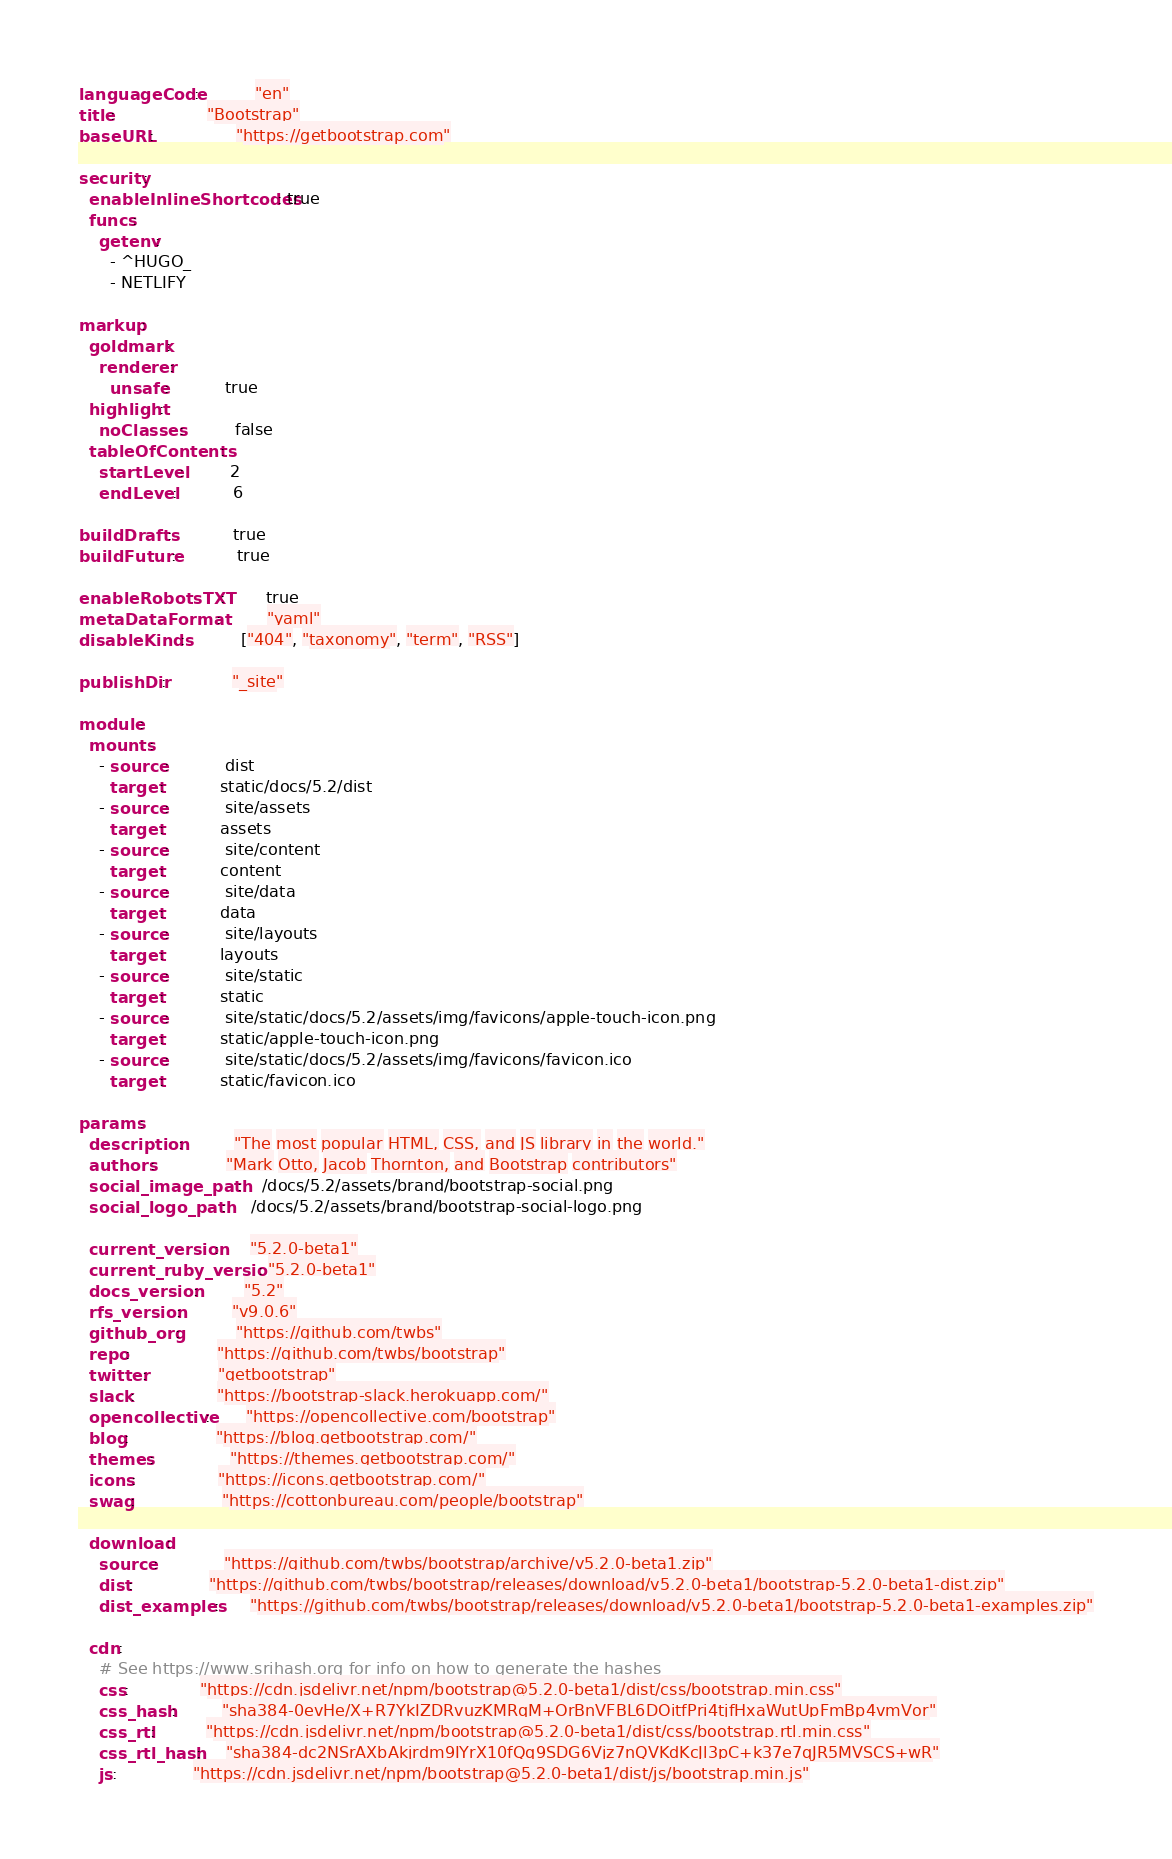<code> <loc_0><loc_0><loc_500><loc_500><_YAML_>languageCode:           "en"
title:                  "Bootstrap"
baseURL:                "https://getbootstrap.com"

security:
  enableInlineShortcodes: true
  funcs:
    getenv:
      - ^HUGO_
      - NETLIFY

markup:
  goldmark:
    renderer:
      unsafe:           true
  highlight:
    noClasses:          false
  tableOfContents:
    startLevel:         2
    endLevel:           6

buildDrafts:            true
buildFuture:            true

enableRobotsTXT:        true
metaDataFormat:         "yaml"
disableKinds:           ["404", "taxonomy", "term", "RSS"]

publishDir:             "_site"

module:
  mounts:
    - source:           dist
      target:           static/docs/5.2/dist
    - source:           site/assets
      target:           assets
    - source:           site/content
      target:           content
    - source:           site/data
      target:           data
    - source:           site/layouts
      target:           layouts
    - source:           site/static
      target:           static
    - source:           site/static/docs/5.2/assets/img/favicons/apple-touch-icon.png
      target:           static/apple-touch-icon.png
    - source:           site/static/docs/5.2/assets/img/favicons/favicon.ico
      target:           static/favicon.ico

params:
  description:          "The most popular HTML, CSS, and JS library in the world."
  authors:              "Mark Otto, Jacob Thornton, and Bootstrap contributors"
  social_image_path:    /docs/5.2/assets/brand/bootstrap-social.png
  social_logo_path:     /docs/5.2/assets/brand/bootstrap-social-logo.png

  current_version:      "5.2.0-beta1"
  current_ruby_version: "5.2.0-beta1"
  docs_version:         "5.2"
  rfs_version:          "v9.0.6"
  github_org:           "https://github.com/twbs"
  repo:                 "https://github.com/twbs/bootstrap"
  twitter:              "getbootstrap"
  slack:                "https://bootstrap-slack.herokuapp.com/"
  opencollective:       "https://opencollective.com/bootstrap"
  blog:                 "https://blog.getbootstrap.com/"
  themes:               "https://themes.getbootstrap.com/"
  icons:                "https://icons.getbootstrap.com/"
  swag:                 "https://cottonbureau.com/people/bootstrap"

  download:
    source:             "https://github.com/twbs/bootstrap/archive/v5.2.0-beta1.zip"
    dist:               "https://github.com/twbs/bootstrap/releases/download/v5.2.0-beta1/bootstrap-5.2.0-beta1-dist.zip"
    dist_examples:      "https://github.com/twbs/bootstrap/releases/download/v5.2.0-beta1/bootstrap-5.2.0-beta1-examples.zip"

  cdn:
    # See https://www.srihash.org for info on how to generate the hashes
    css:              "https://cdn.jsdelivr.net/npm/bootstrap@5.2.0-beta1/dist/css/bootstrap.min.css"
    css_hash:         "sha384-0evHe/X+R7YkIZDRvuzKMRqM+OrBnVFBL6DOitfPri4tjfHxaWutUpFmBp4vmVor"
    css_rtl:          "https://cdn.jsdelivr.net/npm/bootstrap@5.2.0-beta1/dist/css/bootstrap.rtl.min.css"
    css_rtl_hash:     "sha384-dc2NSrAXbAkjrdm9IYrX10fQq9SDG6Vjz7nQVKdKcJl3pC+k37e7qJR5MVSCS+wR"
    js:               "https://cdn.jsdelivr.net/npm/bootstrap@5.2.0-beta1/dist/js/bootstrap.min.js"</code> 